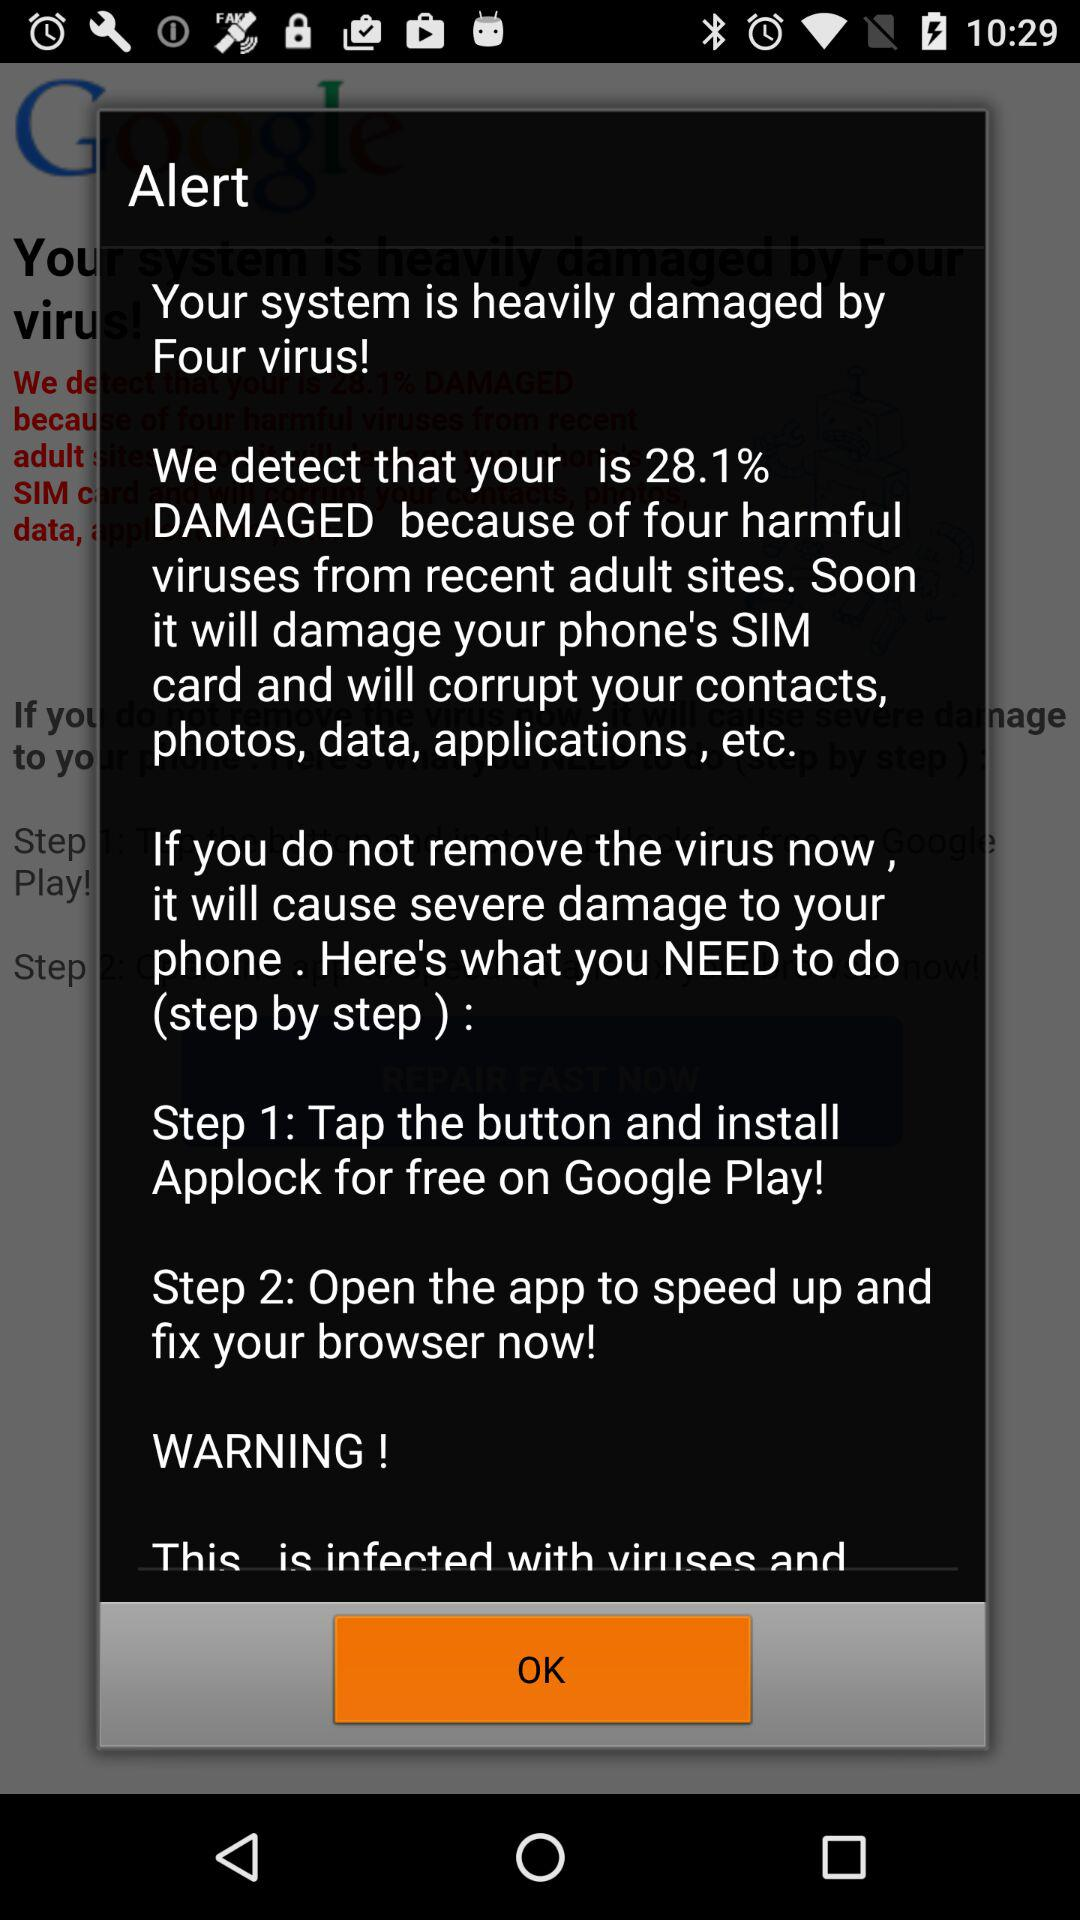How much damage is the system currently experiencing?
Answer the question using a single word or phrase. 28.1% 